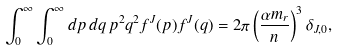Convert formula to latex. <formula><loc_0><loc_0><loc_500><loc_500>\int _ { 0 } ^ { \infty } \int _ { 0 } ^ { \infty } d p \, d q \, p ^ { 2 } q ^ { 2 } f ^ { J } ( p ) f ^ { J } ( q ) = 2 \pi \left ( \frac { \alpha m _ { r } } { n } \right ) ^ { 3 } \delta _ { J , 0 } ,</formula> 